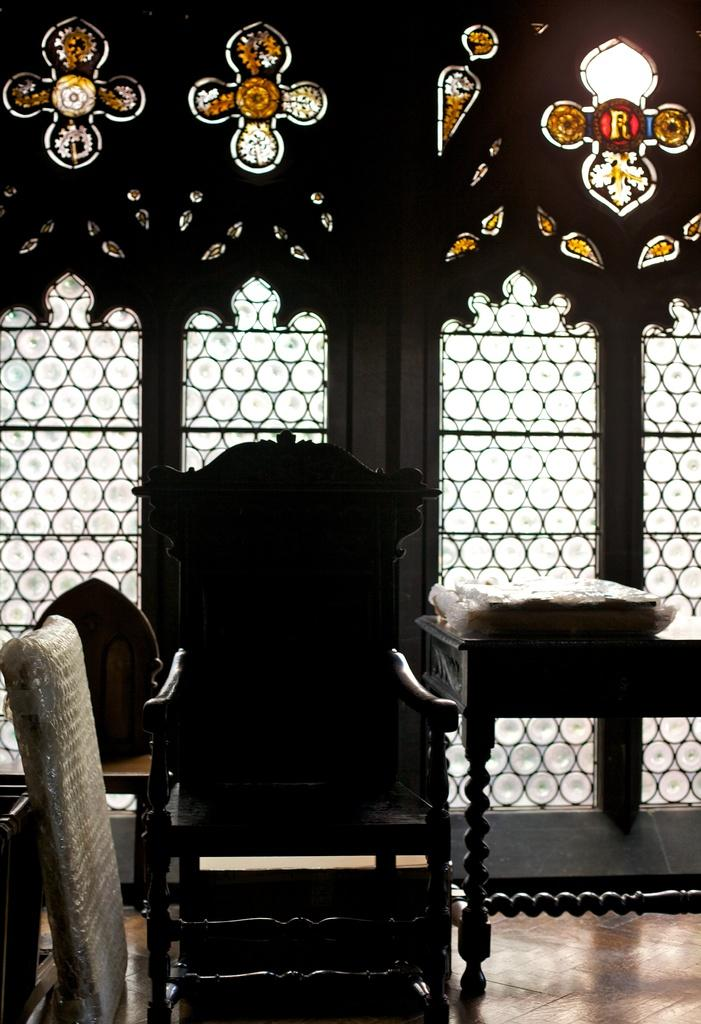What type of furniture is present in the image? There is a chair and a table in the image. What is placed on the table? A carry bag is placed on the table. Is there any source of natural light in the image? Yes, there is a window in the image. What is special about the window? The window has designer glass. Can you see anyone kissing or kicking in the image? There is no indication of anyone kissing or kicking in the image. 